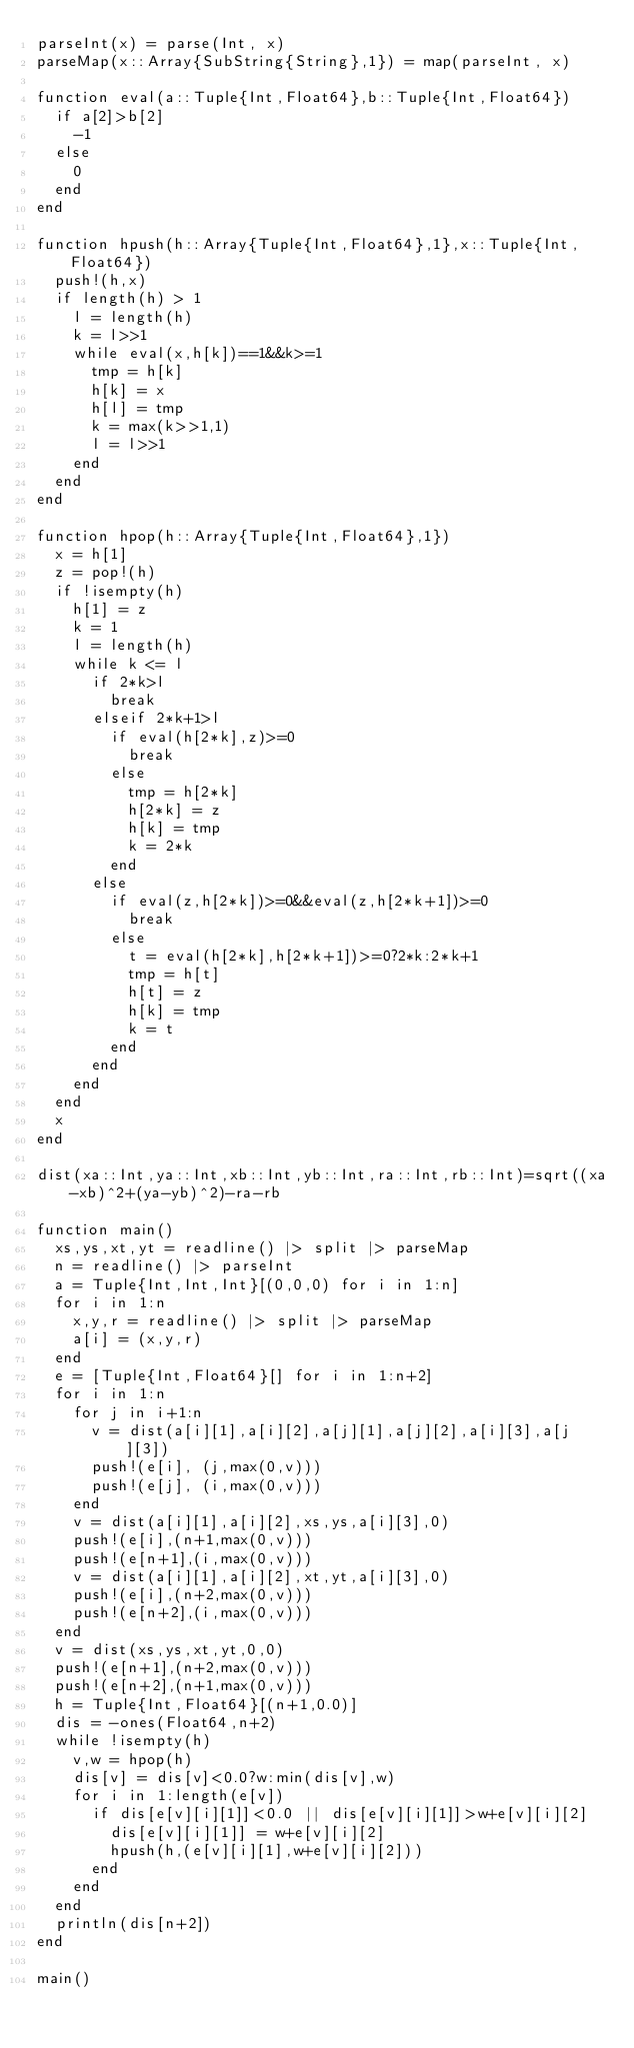<code> <loc_0><loc_0><loc_500><loc_500><_Julia_>parseInt(x) = parse(Int, x)
parseMap(x::Array{SubString{String},1}) = map(parseInt, x)

function eval(a::Tuple{Int,Float64},b::Tuple{Int,Float64})
	if a[2]>b[2]
		-1
	else
		0
	end
end

function hpush(h::Array{Tuple{Int,Float64},1},x::Tuple{Int,Float64})
	push!(h,x)
	if length(h) > 1
		l = length(h)
		k = l>>1
		while eval(x,h[k])==1&&k>=1
			tmp = h[k]
			h[k] = x
			h[l] = tmp
			k = max(k>>1,1)
			l = l>>1
		end
	end
end

function hpop(h::Array{Tuple{Int,Float64},1})
	x = h[1]
	z = pop!(h)
	if !isempty(h)
		h[1] = z
		k = 1
		l = length(h)
		while k <= l
			if 2*k>l
				break
			elseif 2*k+1>l
				if eval(h[2*k],z)>=0
					break
				else
					tmp = h[2*k]
					h[2*k] = z
					h[k] = tmp
					k = 2*k
				end
			else
				if eval(z,h[2*k])>=0&&eval(z,h[2*k+1])>=0
					break
				else
					t = eval(h[2*k],h[2*k+1])>=0?2*k:2*k+1
					tmp = h[t]
					h[t] = z
					h[k] = tmp
					k = t
				end
			end
		end
	end
	x
end

dist(xa::Int,ya::Int,xb::Int,yb::Int,ra::Int,rb::Int)=sqrt((xa-xb)^2+(ya-yb)^2)-ra-rb

function main()
	xs,ys,xt,yt = readline() |> split |> parseMap
	n = readline() |> parseInt
	a = Tuple{Int,Int,Int}[(0,0,0) for i in 1:n]
	for i in 1:n
		x,y,r = readline() |> split |> parseMap
		a[i] = (x,y,r)
	end
	e = [Tuple{Int,Float64}[] for i in 1:n+2]
	for i in 1:n
		for j in i+1:n
			v = dist(a[i][1],a[i][2],a[j][1],a[j][2],a[i][3],a[j][3])
			push!(e[i], (j,max(0,v)))
			push!(e[j], (i,max(0,v)))
		end
		v = dist(a[i][1],a[i][2],xs,ys,a[i][3],0)
		push!(e[i],(n+1,max(0,v)))
		push!(e[n+1],(i,max(0,v)))
		v = dist(a[i][1],a[i][2],xt,yt,a[i][3],0)
		push!(e[i],(n+2,max(0,v)))
		push!(e[n+2],(i,max(0,v)))
	end
	v = dist(xs,ys,xt,yt,0,0)
	push!(e[n+1],(n+2,max(0,v)))
	push!(e[n+2],(n+1,max(0,v)))
	h = Tuple{Int,Float64}[(n+1,0.0)]
	dis = -ones(Float64,n+2)
	while !isempty(h)
		v,w = hpop(h)
		dis[v] = dis[v]<0.0?w:min(dis[v],w)
		for i in 1:length(e[v])
			if dis[e[v][i][1]]<0.0 || dis[e[v][i][1]]>w+e[v][i][2]
				dis[e[v][i][1]] = w+e[v][i][2]
				hpush(h,(e[v][i][1],w+e[v][i][2]))
			end
		end
	end
	println(dis[n+2])
end

main()</code> 